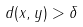Convert formula to latex. <formula><loc_0><loc_0><loc_500><loc_500>d ( x , y ) > \delta</formula> 